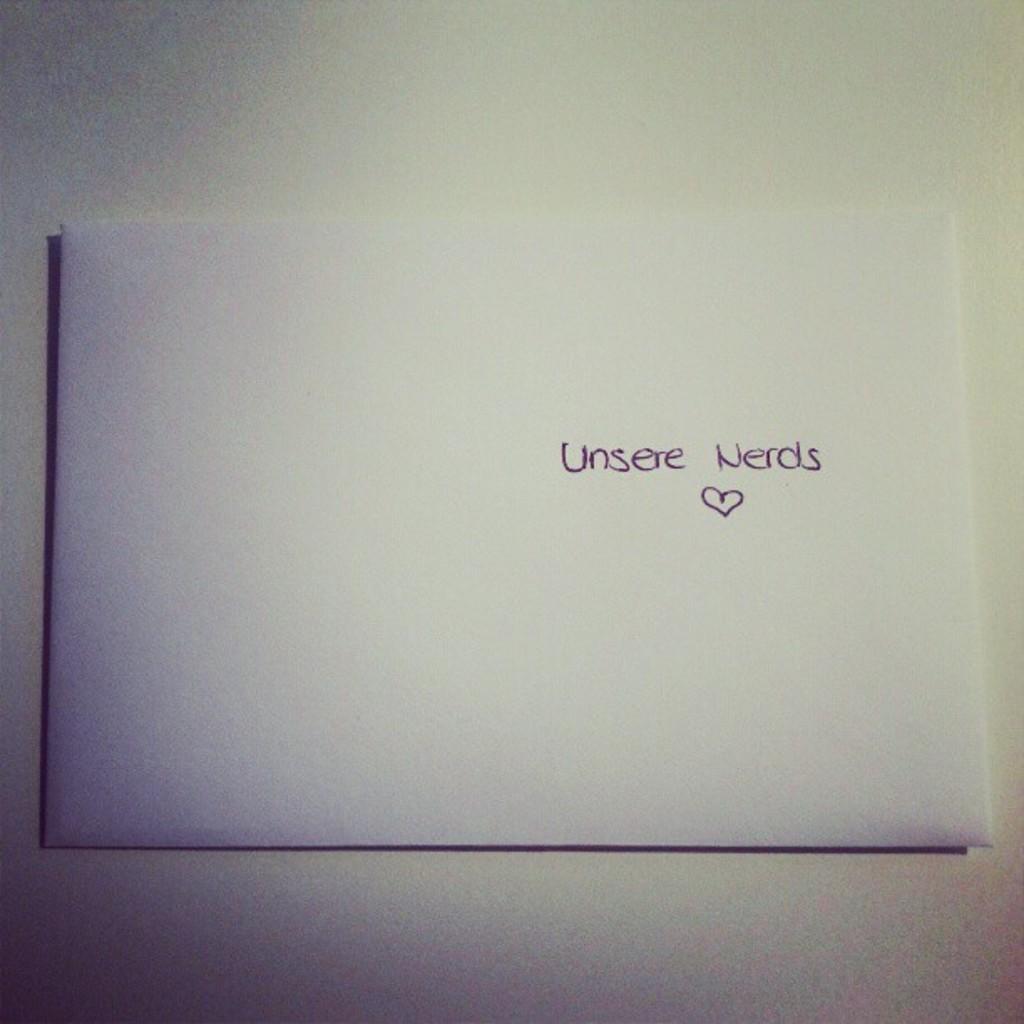What words are above the heart?
Keep it short and to the point. Unsere nerds. 